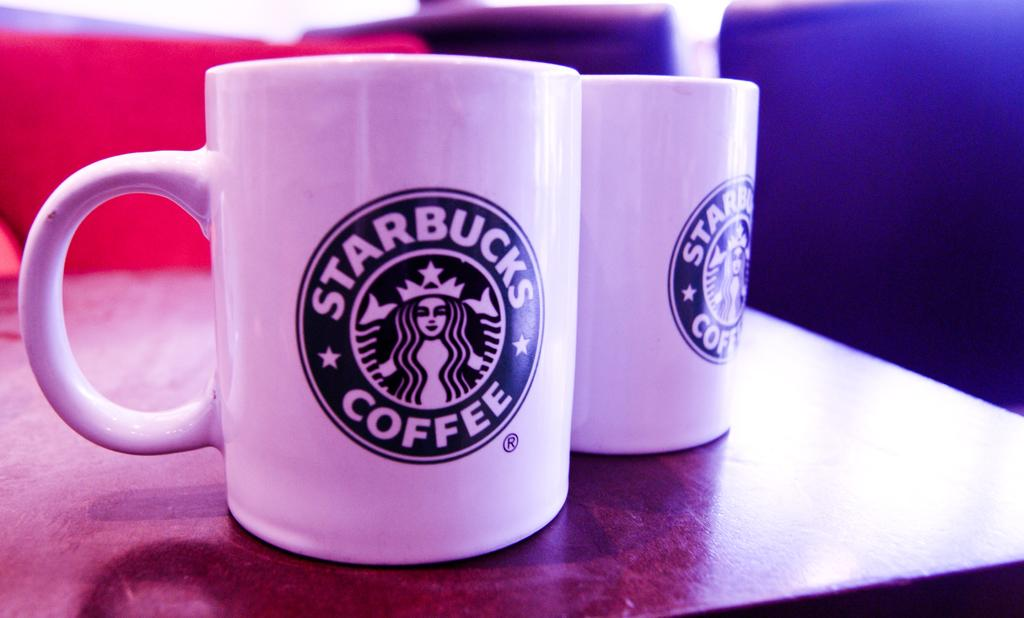<image>
Provide a brief description of the given image. Two white coffee cups with the Starbucks logo on them. 